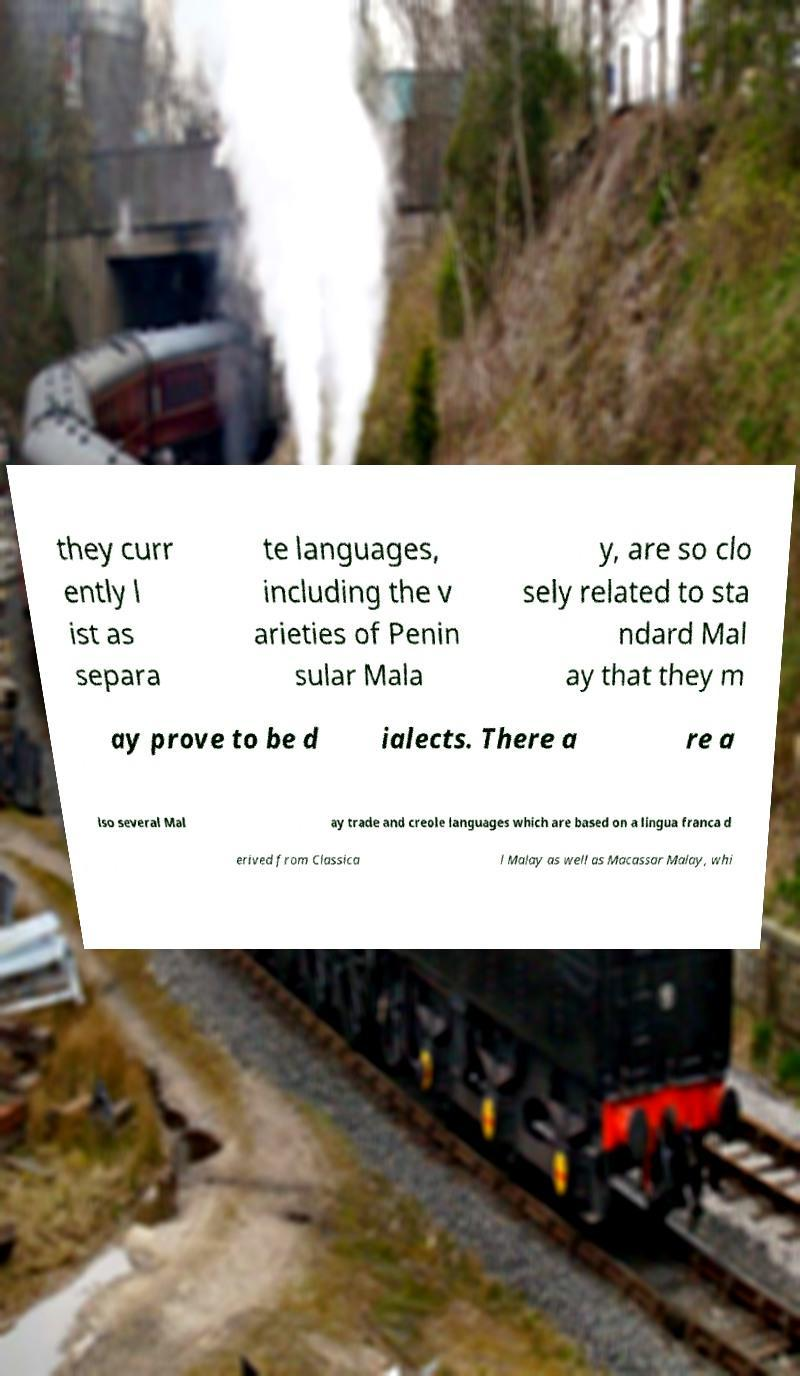Could you assist in decoding the text presented in this image and type it out clearly? they curr ently l ist as separa te languages, including the v arieties of Penin sular Mala y, are so clo sely related to sta ndard Mal ay that they m ay prove to be d ialects. There a re a lso several Mal ay trade and creole languages which are based on a lingua franca d erived from Classica l Malay as well as Macassar Malay, whi 